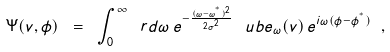Convert formula to latex. <formula><loc_0><loc_0><loc_500><loc_500>\Psi ( v , \phi ) \ = \ \int _ { 0 } ^ { \infty } \ r d \omega \, e ^ { - \frac { ( \omega - \omega ^ { ^ { * } } ) ^ { 2 } } { 2 \sigma ^ { 2 } } } \, \ u b { e } _ { \omega } ( v ) \, e ^ { i \omega ( \phi - \phi ^ { ^ { * } } ) } \ ,</formula> 